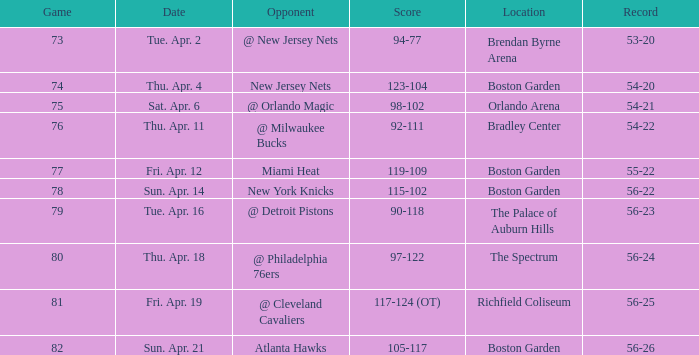In which location was game 78 held? Boston Garden. 